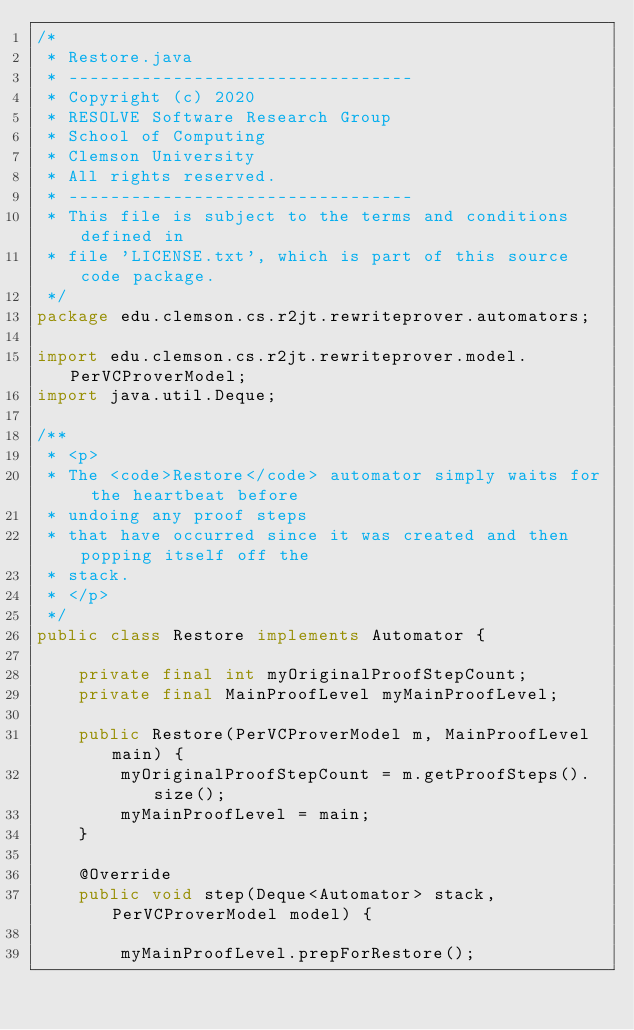Convert code to text. <code><loc_0><loc_0><loc_500><loc_500><_Java_>/*
 * Restore.java
 * ---------------------------------
 * Copyright (c) 2020
 * RESOLVE Software Research Group
 * School of Computing
 * Clemson University
 * All rights reserved.
 * ---------------------------------
 * This file is subject to the terms and conditions defined in
 * file 'LICENSE.txt', which is part of this source code package.
 */
package edu.clemson.cs.r2jt.rewriteprover.automators;

import edu.clemson.cs.r2jt.rewriteprover.model.PerVCProverModel;
import java.util.Deque;

/**
 * <p>
 * The <code>Restore</code> automator simply waits for the heartbeat before
 * undoing any proof steps
 * that have occurred since it was created and then popping itself off the
 * stack.
 * </p>
 */
public class Restore implements Automator {

    private final int myOriginalProofStepCount;
    private final MainProofLevel myMainProofLevel;

    public Restore(PerVCProverModel m, MainProofLevel main) {
        myOriginalProofStepCount = m.getProofSteps().size();
        myMainProofLevel = main;
    }

    @Override
    public void step(Deque<Automator> stack, PerVCProverModel model) {

        myMainProofLevel.prepForRestore();
</code> 